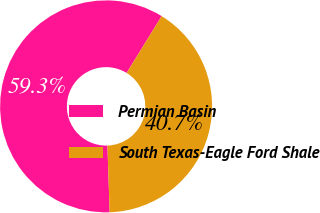<chart> <loc_0><loc_0><loc_500><loc_500><pie_chart><fcel>Permian Basin<fcel>South Texas-Eagle Ford Shale<nl><fcel>59.32%<fcel>40.68%<nl></chart> 